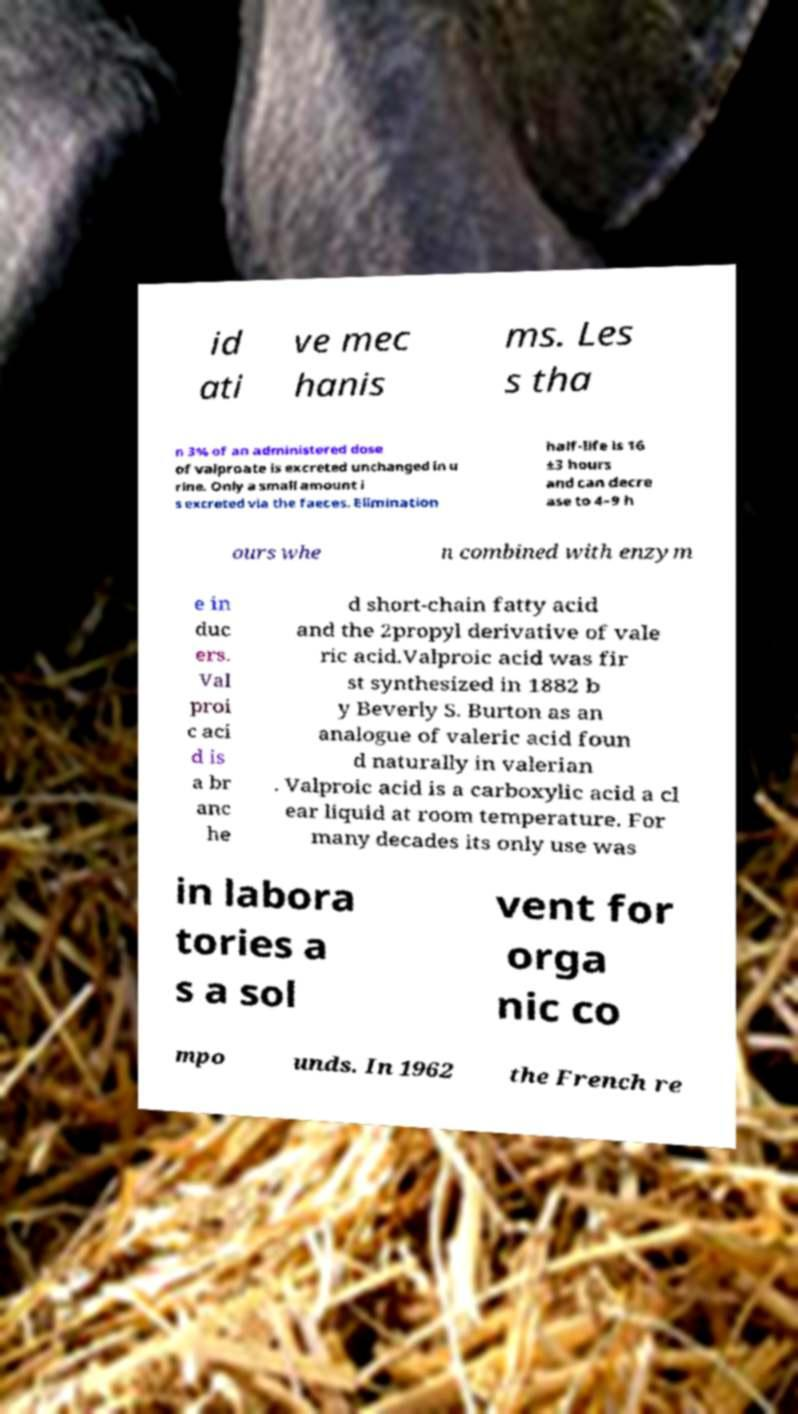I need the written content from this picture converted into text. Can you do that? id ati ve mec hanis ms. Les s tha n 3% of an administered dose of valproate is excreted unchanged in u rine. Only a small amount i s excreted via the faeces. Elimination half-life is 16 ±3 hours and can decre ase to 4–9 h ours whe n combined with enzym e in duc ers. Val proi c aci d is a br anc he d short-chain fatty acid and the 2propyl derivative of vale ric acid.Valproic acid was fir st synthesized in 1882 b y Beverly S. Burton as an analogue of valeric acid foun d naturally in valerian . Valproic acid is a carboxylic acid a cl ear liquid at room temperature. For many decades its only use was in labora tories a s a sol vent for orga nic co mpo unds. In 1962 the French re 